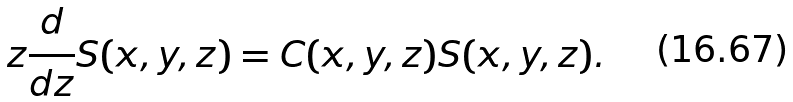Convert formula to latex. <formula><loc_0><loc_0><loc_500><loc_500>z \frac { d } { d z } S ( x , y , z ) = C ( x , y , z ) S ( x , y , z ) .</formula> 